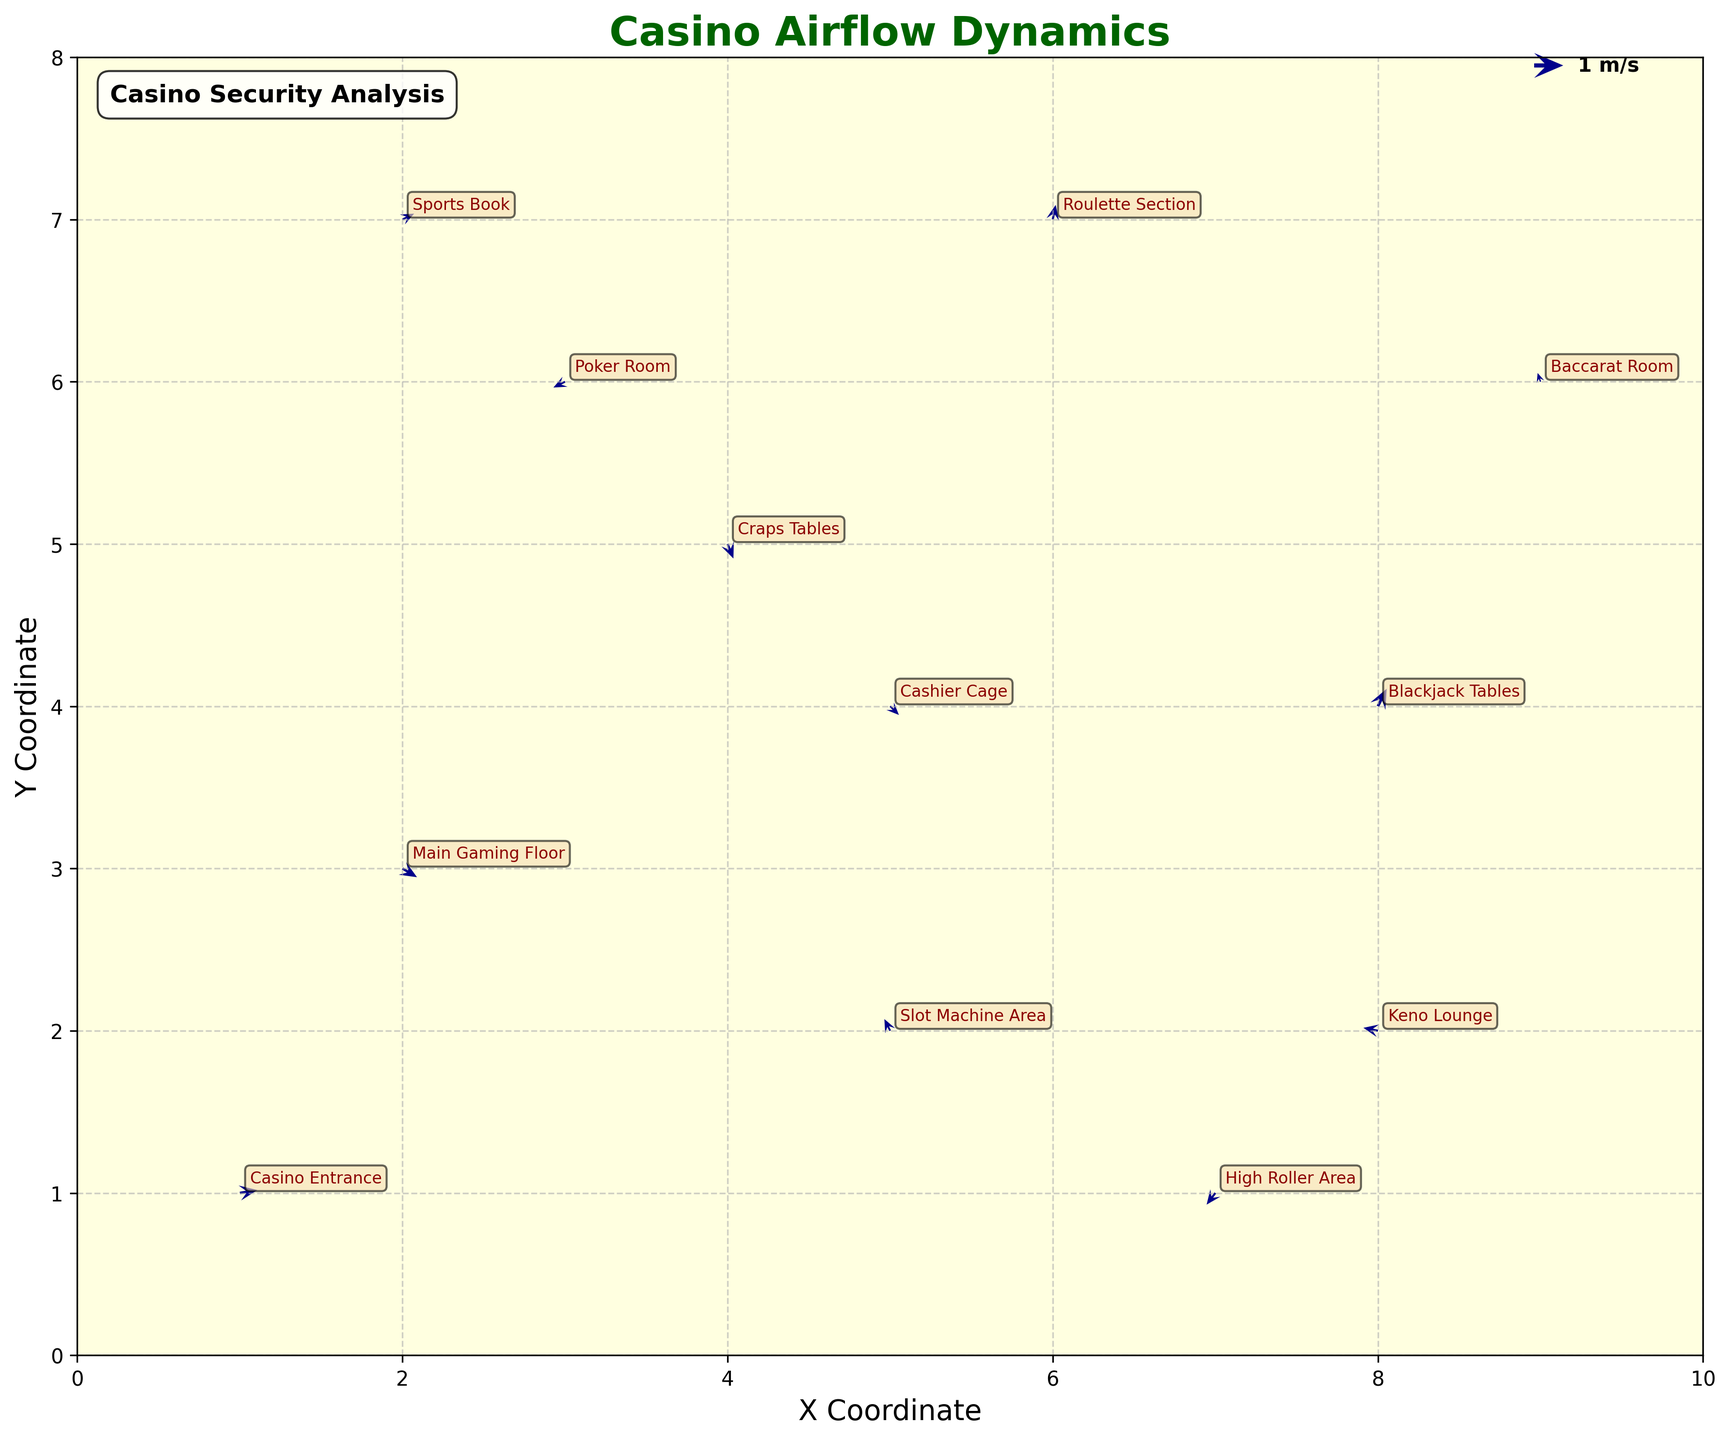Which location has the highest velocity air current? To identify the highest velocity air current, we need to calculate the magnitude for each vector using the formula sqrt(u^2 + v^2). By doing this for each location, we find that the Blackjack Tables have the highest magnitude with sqrt(0.3^2 + 0.6^2) = 0.67.
Answer: Blackjack Tables What is the direction of airflow at the Casino Entrance? The airflow direction can be represented by the vector (u, v). For the Casino Entrance, the vector is (0.6, 0.1). This indicates a mostly rightward and slightly upward direction.
Answer: Mostly rightward and slightly upward Which two locations have directly opposite airflow directions? First, we need to compare the direction vectors (u, v) for each location. The High Roller Area has a vector (-0.3, -0.4) and Keno Lounge has a vector (0.5, -0.1). Though not perfectly opposite, they are the closest pair with reversed signs in their x-component, showing a near-opposite airflow direction.
Answer: High Roller Area and Keno Lounge How many data points are used to generate the plot? Each point on the plot represents a location with an (x, y) coordinate and corresponding airflow vector (u, v). There are 12 rows in the data frame, indicating there are 12 data points.
Answer: 12 Is the airflow direction at the Sports Book more horizontally dominated or vertically dominated? To determine this, compare the absolute values of the horizontal and vertical components. For Sports Book, the vector is (0.4, 0.2). Since 0.4 > 0.2, it's more horizontally dominated.
Answer: Horizontally dominated Which location has the largest negative horizontal component of airflow? By examining the u component for each location, the Keno Lounge has the largest negative horizontal component with u = -0.5.
Answer: Keno Lounge 